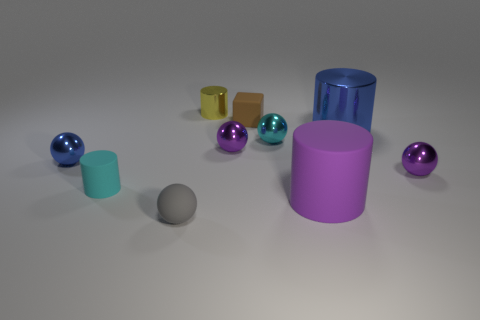Subtract all small matte cylinders. How many cylinders are left? 3 Subtract 3 spheres. How many spheres are left? 2 Subtract all blue spheres. How many spheres are left? 4 Add 5 tiny purple objects. How many tiny purple objects are left? 7 Add 4 tiny cyan matte cylinders. How many tiny cyan matte cylinders exist? 5 Subtract 2 purple spheres. How many objects are left? 8 Subtract all cylinders. How many objects are left? 6 Subtract all purple cylinders. Subtract all green blocks. How many cylinders are left? 3 Subtract all brown blocks. How many gray balls are left? 1 Subtract all small metal cylinders. Subtract all big purple rubber cylinders. How many objects are left? 8 